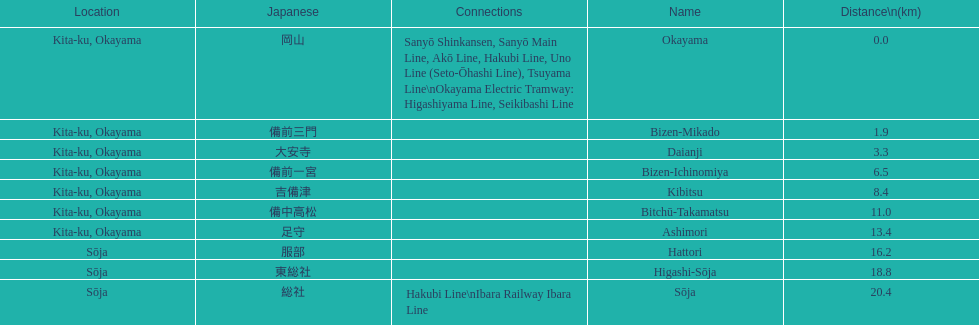Which has a distance less than 3.0 kilometers? Bizen-Mikado. Can you give me this table as a dict? {'header': ['Location', 'Japanese', 'Connections', 'Name', 'Distance\\n(km)'], 'rows': [['Kita-ku, Okayama', '岡山', 'Sanyō Shinkansen, Sanyō Main Line, Akō Line, Hakubi Line, Uno Line (Seto-Ōhashi Line), Tsuyama Line\\nOkayama Electric Tramway: Higashiyama Line, Seikibashi Line', 'Okayama', '0.0'], ['Kita-ku, Okayama', '備前三門', '', 'Bizen-Mikado', '1.9'], ['Kita-ku, Okayama', '大安寺', '', 'Daianji', '3.3'], ['Kita-ku, Okayama', '備前一宮', '', 'Bizen-Ichinomiya', '6.5'], ['Kita-ku, Okayama', '吉備津', '', 'Kibitsu', '8.4'], ['Kita-ku, Okayama', '備中高松', '', 'Bitchū-Takamatsu', '11.0'], ['Kita-ku, Okayama', '足守', '', 'Ashimori', '13.4'], ['Sōja', '服部', '', 'Hattori', '16.2'], ['Sōja', '東総社', '', 'Higashi-Sōja', '18.8'], ['Sōja', '総社', 'Hakubi Line\\nIbara Railway Ibara Line', 'Sōja', '20.4']]} 